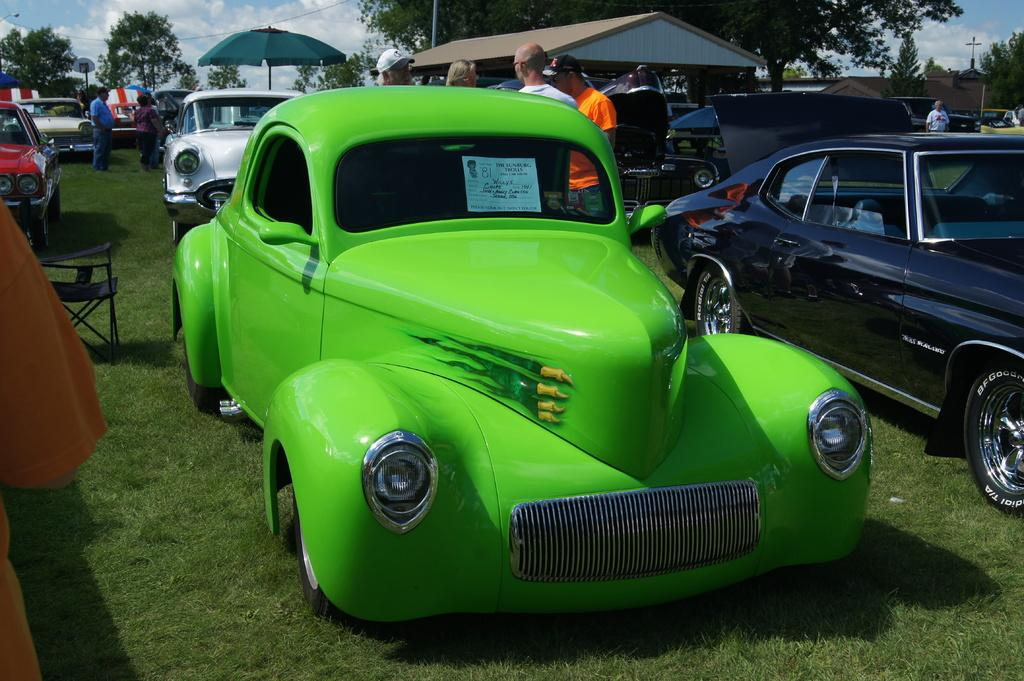What can be seen in the image? There are many vehicles in the image. What else can be seen in the background of the image? There are people, sheds, tents, and trees in the background of the image. What is visible at the bottom of the image? The ground is visible at the bottom of the image. What is visible at the top of the image? There are clouds in the sky at the top of the image. What type of alarm can be heard going off in the image? There is no alarm present in the image, and therefore no sound can be heard. What kind of knife is being used by the person in the image? There are no knives or people performing actions visible in the image. 